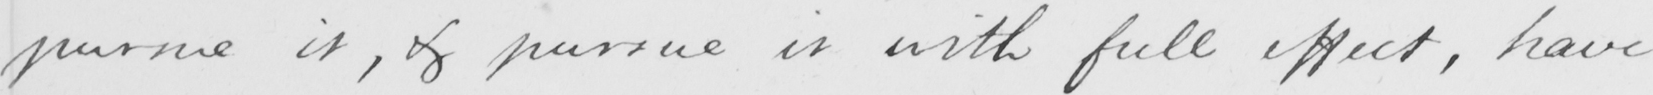Please provide the text content of this handwritten line. pursue it , & pursue it with full effect , have 